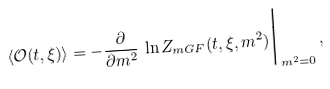<formula> <loc_0><loc_0><loc_500><loc_500>\langle \mathcal { O } ( t , \xi ) \rangle = - \frac { \partial } { \partial m ^ { 2 } } \, \ln Z _ { m G F } ( t , \xi , m ^ { 2 } ) \Big | _ { m ^ { 2 } = 0 } \, ,</formula> 